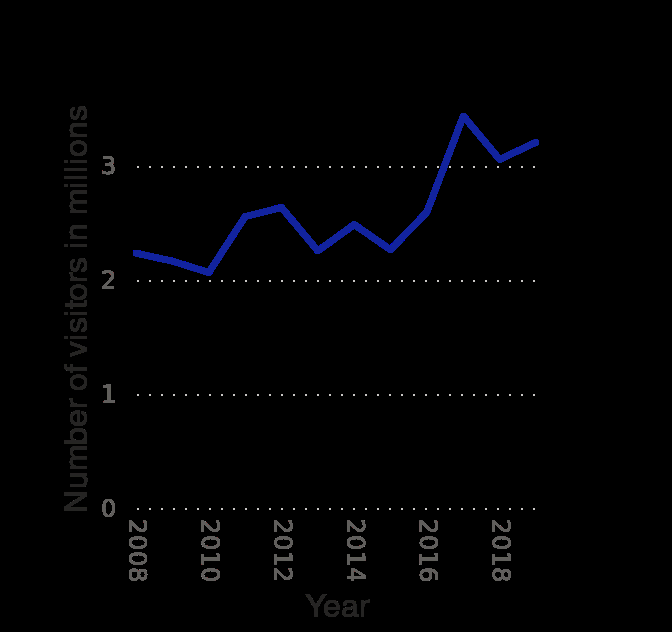<image>
In which years did the visitor count experience a significant rise? The visitor count significantly rose between 2016 and 2018. What is the lowest recorded number of visitors to Boston National Historical Park? The lowest recorded number of visitors to Boston National Historical Park is not given in the description. 